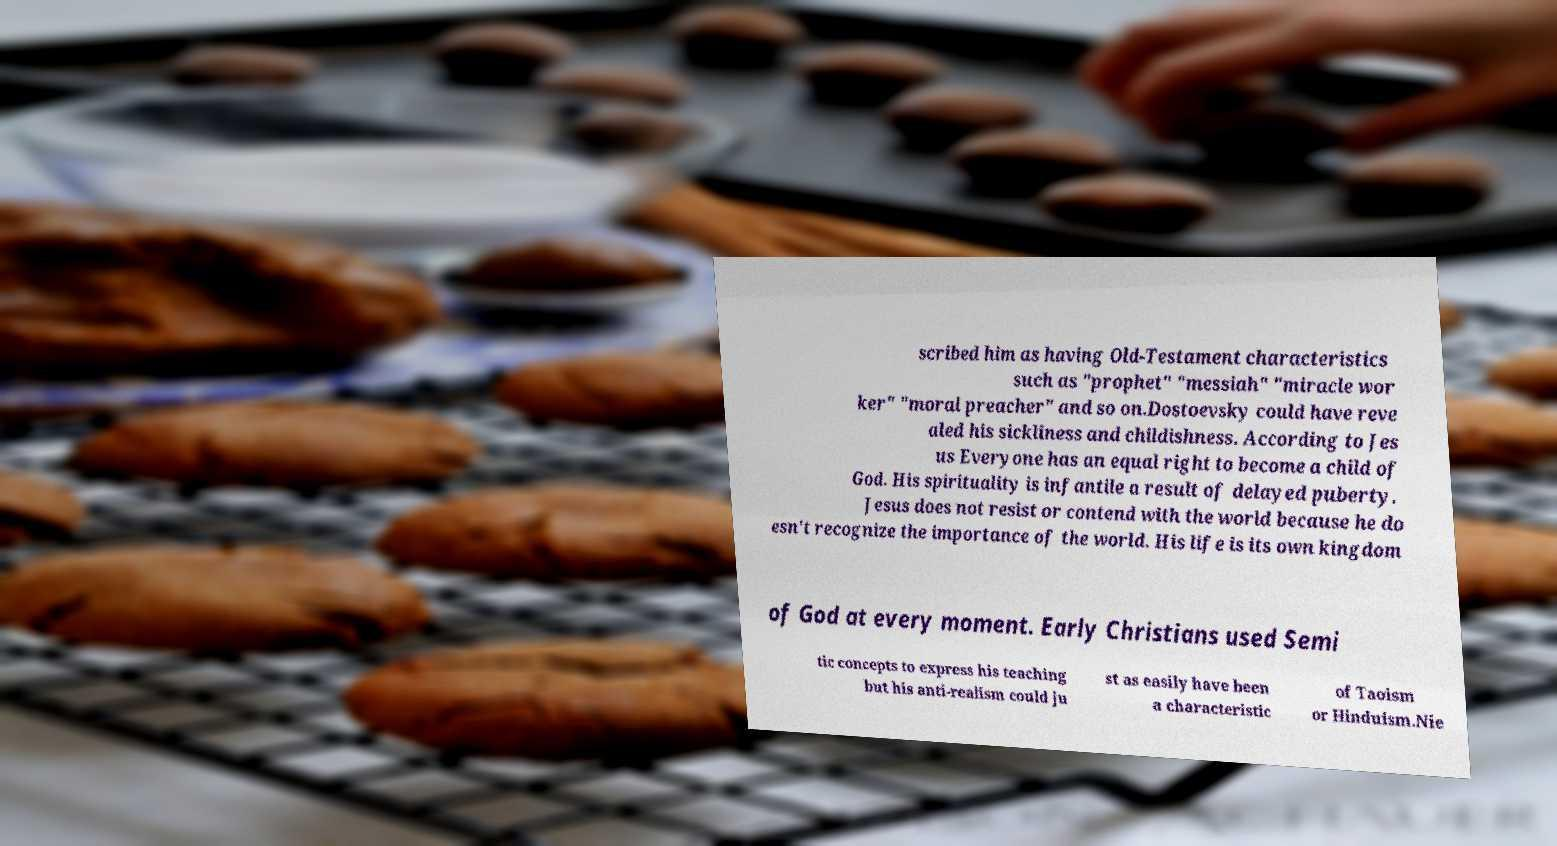Can you read and provide the text displayed in the image?This photo seems to have some interesting text. Can you extract and type it out for me? scribed him as having Old-Testament characteristics such as "prophet" "messiah" "miracle wor ker" "moral preacher" and so on.Dostoevsky could have reve aled his sickliness and childishness. According to Jes us Everyone has an equal right to become a child of God. His spirituality is infantile a result of delayed puberty. Jesus does not resist or contend with the world because he do esn't recognize the importance of the world. His life is its own kingdom of God at every moment. Early Christians used Semi tic concepts to express his teaching but his anti-realism could ju st as easily have been a characteristic of Taoism or Hinduism.Nie 